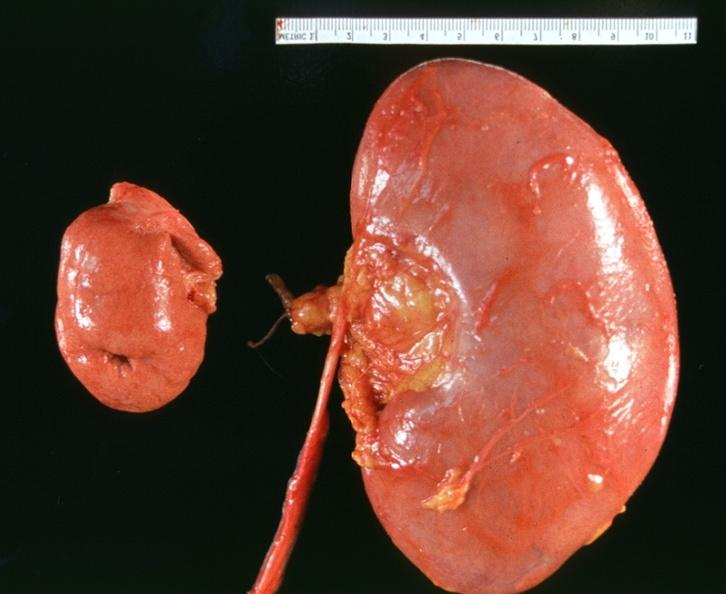does this image show hyoplasia of kidney?
Answer the question using a single word or phrase. Yes 